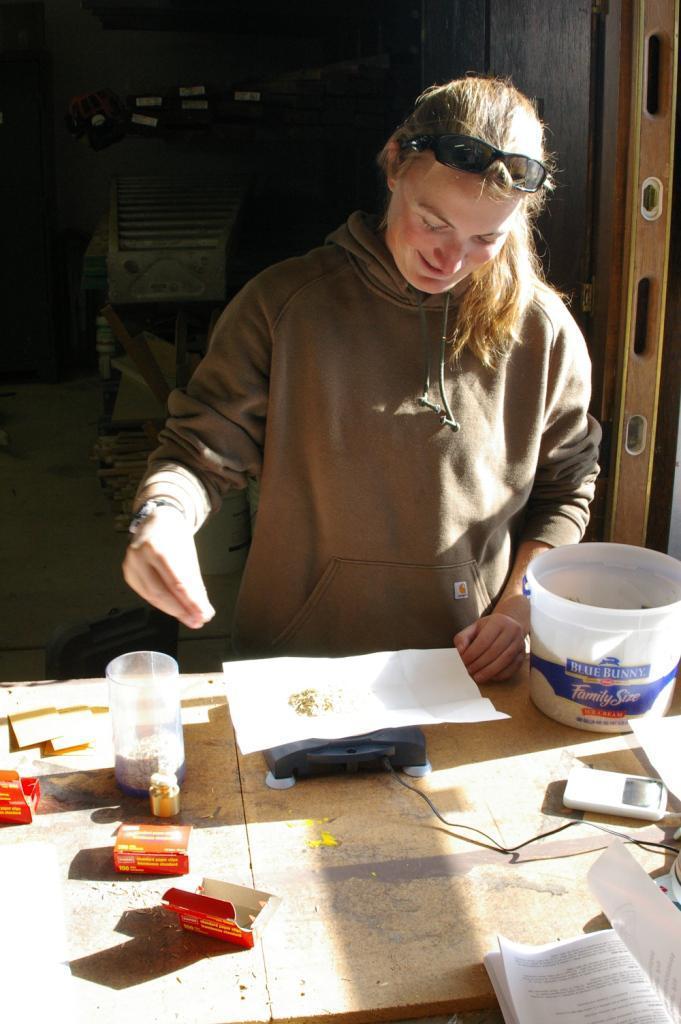Can you describe this image briefly? in the picture we can see a person standing near the table and doing some thing,on the table we can see a paper a book and a cardboard boxes along with a glass. 